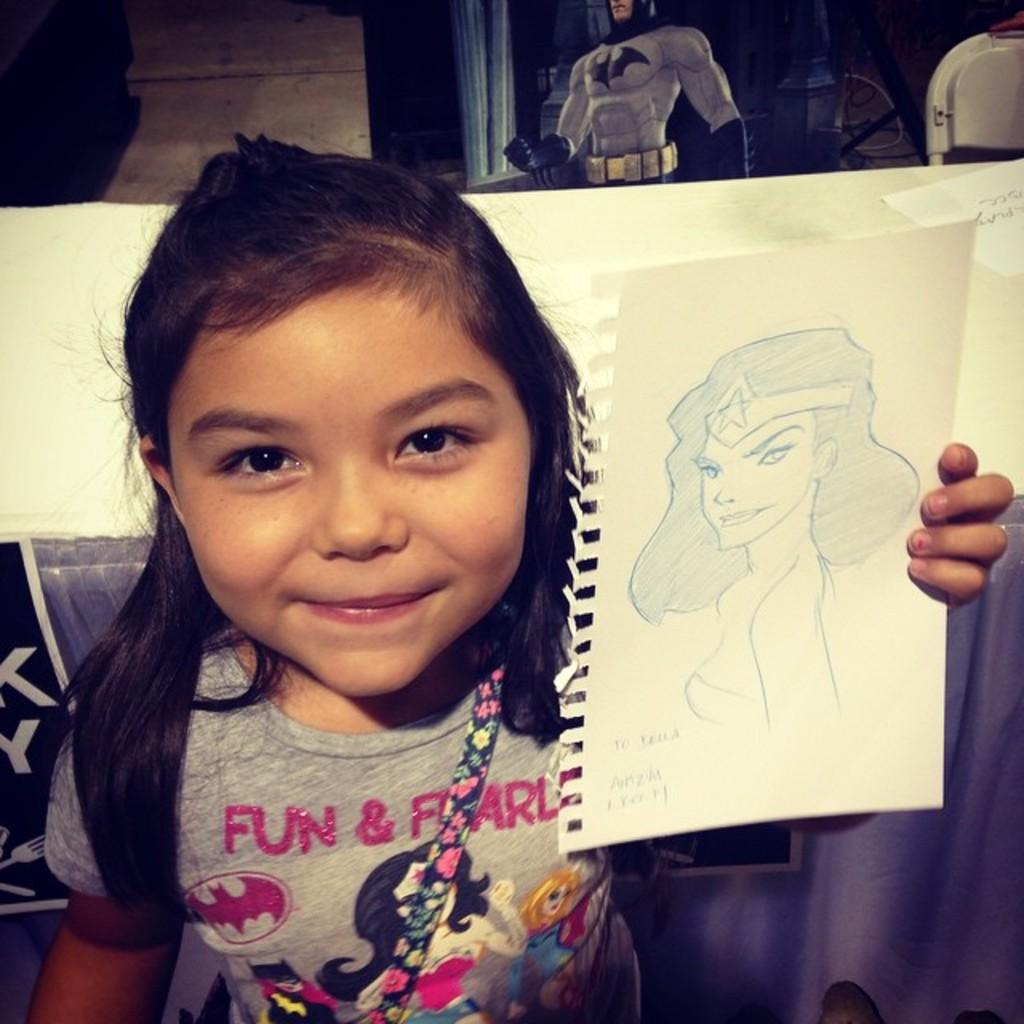Who is the main subject in the image? There is a girl in the image. What is the girl doing in the image? The girl is smiling and drawing on a paper. What is the girl holding in her hand? The girl is holding a paper in her hand. What type of cord is the girl using to draw on the paper? There is no cord present in the image; the girl is drawing on the paper using a pen or pencil. 